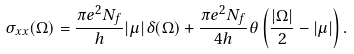Convert formula to latex. <formula><loc_0><loc_0><loc_500><loc_500>\sigma _ { x x } ( \Omega ) = \frac { \pi e ^ { 2 } N _ { f } } { h } | \mu | \delta ( \Omega ) + \frac { \pi e ^ { 2 } N _ { f } } { 4 h } \theta \left ( \frac { | \Omega | } { 2 } - | \mu | \right ) .</formula> 